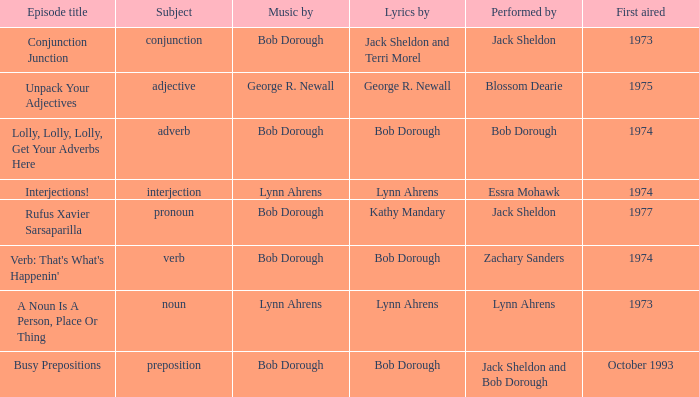When zachary sanders is the artist, how many premieres are there? 1.0. 